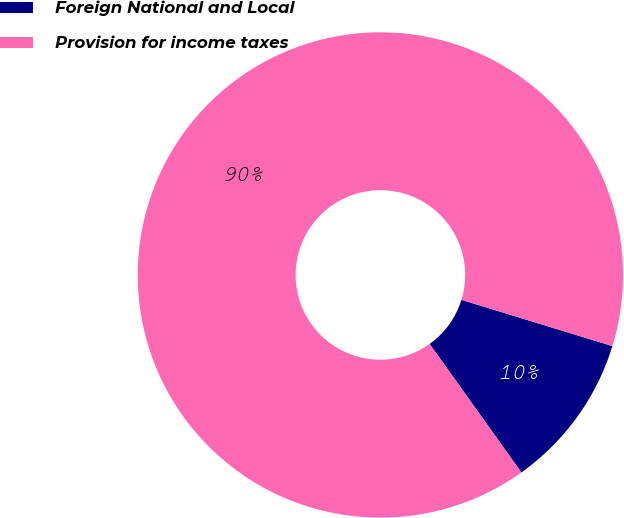<chart> <loc_0><loc_0><loc_500><loc_500><pie_chart><fcel>Foreign National and Local<fcel>Provision for income taxes<nl><fcel>10.4%<fcel>89.6%<nl></chart> 